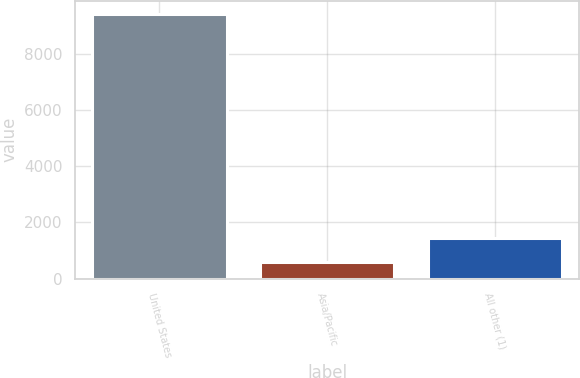Convert chart. <chart><loc_0><loc_0><loc_500><loc_500><bar_chart><fcel>United States<fcel>Asia/Pacific<fcel>All other (1)<nl><fcel>9421<fcel>579<fcel>1463.2<nl></chart> 